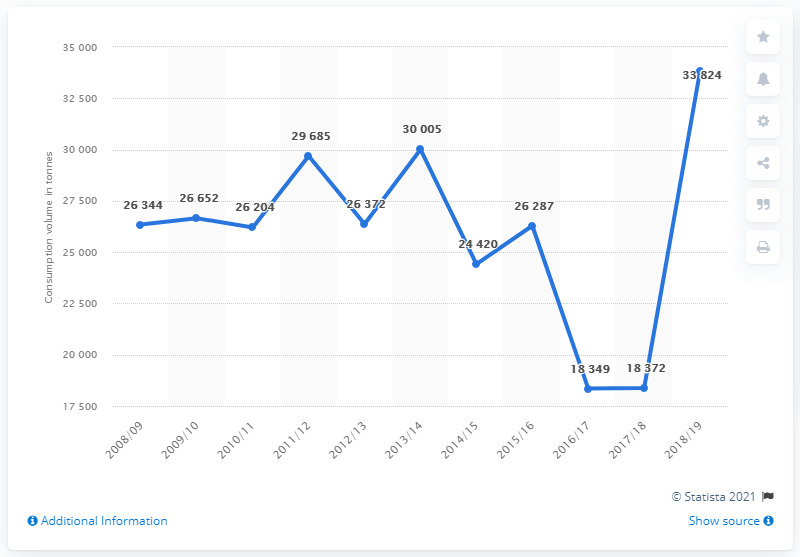Specify some key components in this picture. In 2008/2009, the volume of plums consumed in Austria was 26,204 metric tons. In the 2018/2019 fiscal year, a total of 33,824 metric tons of plums were consumed in Austria. 